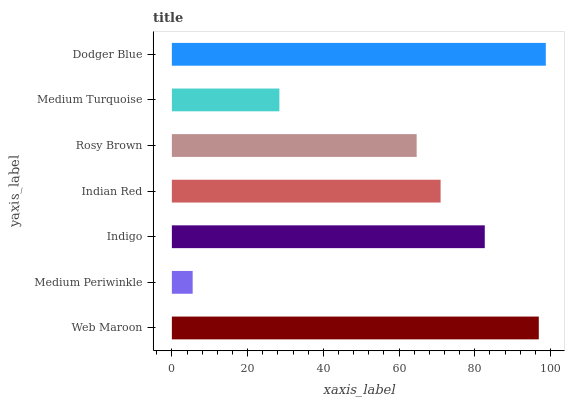Is Medium Periwinkle the minimum?
Answer yes or no. Yes. Is Dodger Blue the maximum?
Answer yes or no. Yes. Is Indigo the minimum?
Answer yes or no. No. Is Indigo the maximum?
Answer yes or no. No. Is Indigo greater than Medium Periwinkle?
Answer yes or no. Yes. Is Medium Periwinkle less than Indigo?
Answer yes or no. Yes. Is Medium Periwinkle greater than Indigo?
Answer yes or no. No. Is Indigo less than Medium Periwinkle?
Answer yes or no. No. Is Indian Red the high median?
Answer yes or no. Yes. Is Indian Red the low median?
Answer yes or no. Yes. Is Rosy Brown the high median?
Answer yes or no. No. Is Medium Turquoise the low median?
Answer yes or no. No. 